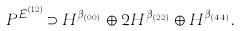<formula> <loc_0><loc_0><loc_500><loc_500>P ^ { \mathcal { E } _ { i } ^ { ( 1 2 ) } } \supset H ^ { \beta _ { ( 0 , 0 ) } } \oplus 2 H ^ { \beta _ { ( 2 , 2 ) } } \oplus H ^ { \beta _ { ( 4 , 4 ) } } .</formula> 